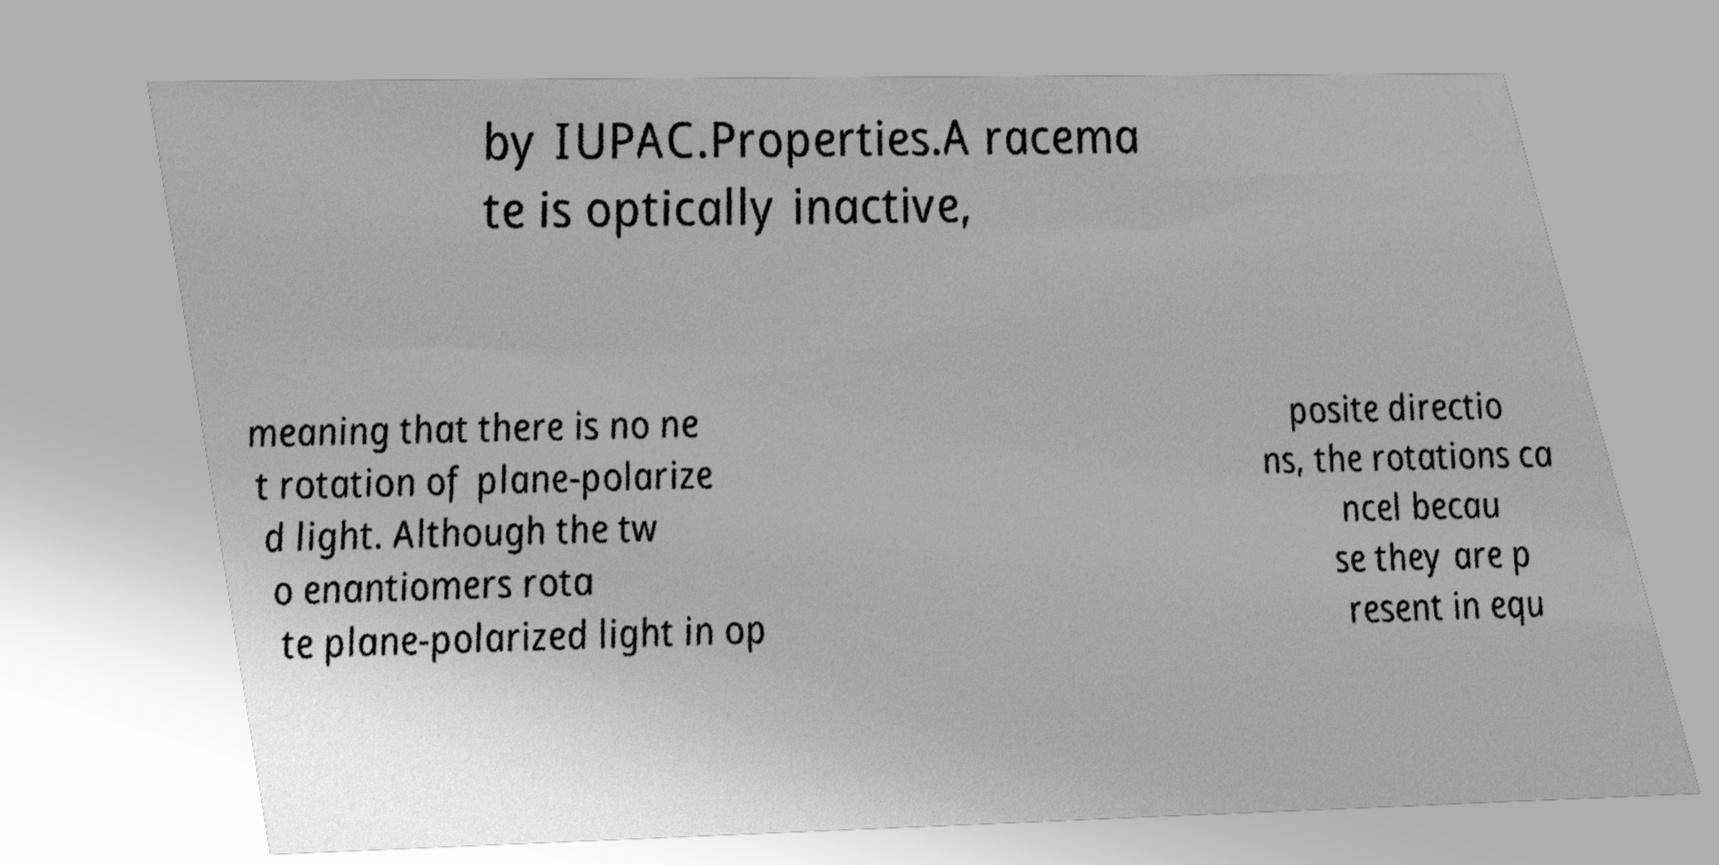Please identify and transcribe the text found in this image. by IUPAC.Properties.A racema te is optically inactive, meaning that there is no ne t rotation of plane-polarize d light. Although the tw o enantiomers rota te plane-polarized light in op posite directio ns, the rotations ca ncel becau se they are p resent in equ 